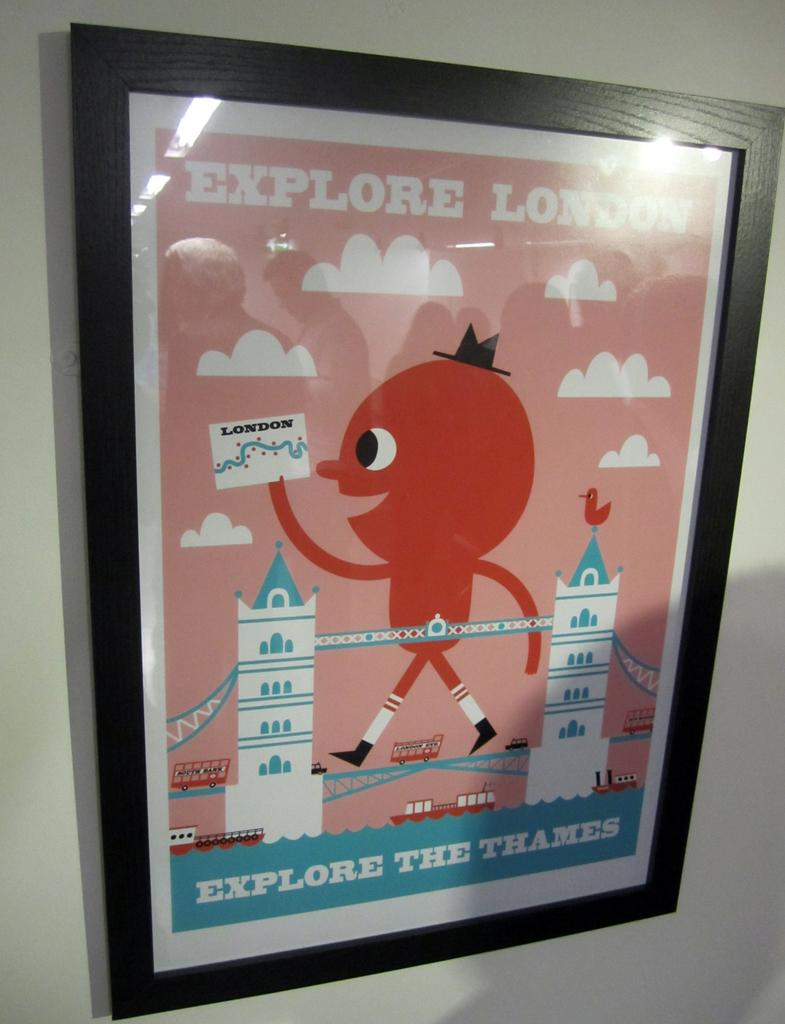<image>
Provide a brief description of the given image. A tourist advertisement shows visitors locations on the Thames river. 